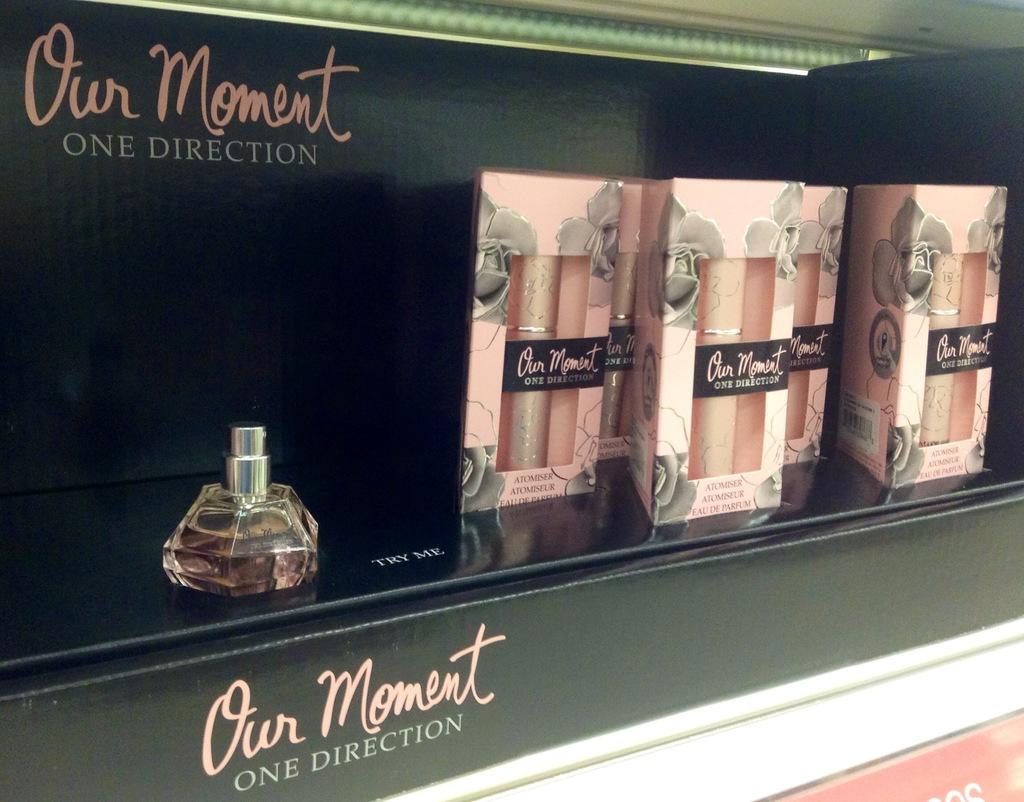<image>
Share a concise interpretation of the image provided. Our Moment by One Direction is displayed against a black background. 